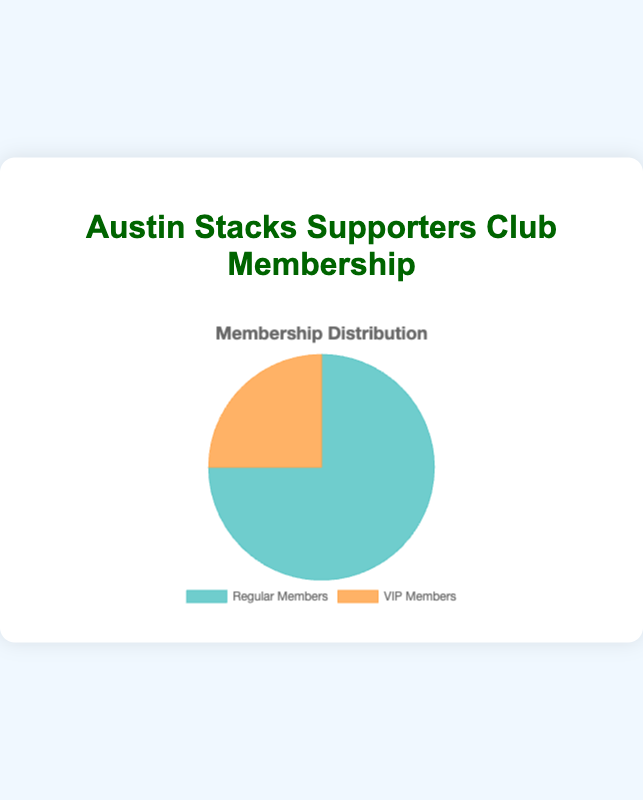What is the total number of club members? To find the total number of club members, sum the counts of Regular Members and VIP Members. So, 150 (Regular Members) + 50 (VIP Members) = 200
Answer: 200 Which group has more members, Regular Members or VIP Members? Compare the data points: Regular Members have 150 members while VIP Members have 50. Since 150 is greater than 50, Regular Members have more members.
Answer: Regular Members What is the percentage of VIP Members in the club? Calculate the percentage by dividing the number of VIP Members by the total number of members and then multiplying by 100. So, (50 / 200) * 100 = 25%
Answer: 25% What is the ratio of Regular Members to VIP Members? The ratio can be found by dividing the number of Regular Members by the number of VIP Members. So, 150 / 50 = 3:1
Answer: 3:1 What fraction of the total membership is made up by Regular Members? The fraction can be calculated by dividing the number of Regular Members by the total number of members. Thus, 150 / 200 = 0.75 or 3/4
Answer: 3/4 If the club gains 30 more Regular Members, what will be the new total membership? Add the new members to the current total of Regular Members and then sum with the VIP Members. New Regular Members = 150 + 30 = 180. So, total membership = 180 + 50 = 230
Answer: 230 By how much do Regular Members exceed VIP Members? Determine the difference between the number of Regular Members and VIP Members. So, 150 - 50 = 100
Answer: 100 If 20 VIP Members upgrade to Regular Members, what will be the new count of each group? Subtract 20 from the VIP Members and add 20 to the Regular Members. So, Regular Members = 150 + 20 = 170, VIP Members = 50 - 20 = 30
Answer: Regular Members = 170, VIP Members = 30 